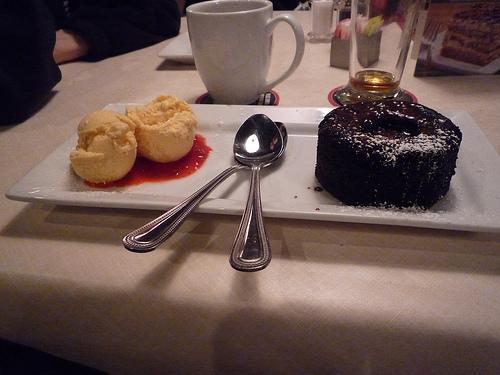How many spoons are there?
Give a very brief answer. 2. How many scoops of ice cream are on the plate?
Give a very brief answer. 2. How many scoops of ice cream are shown?
Give a very brief answer. 2. How many spoon are there?
Give a very brief answer. 2. How many scoops of the ice cream are on the plate?
Give a very brief answer. 2. 